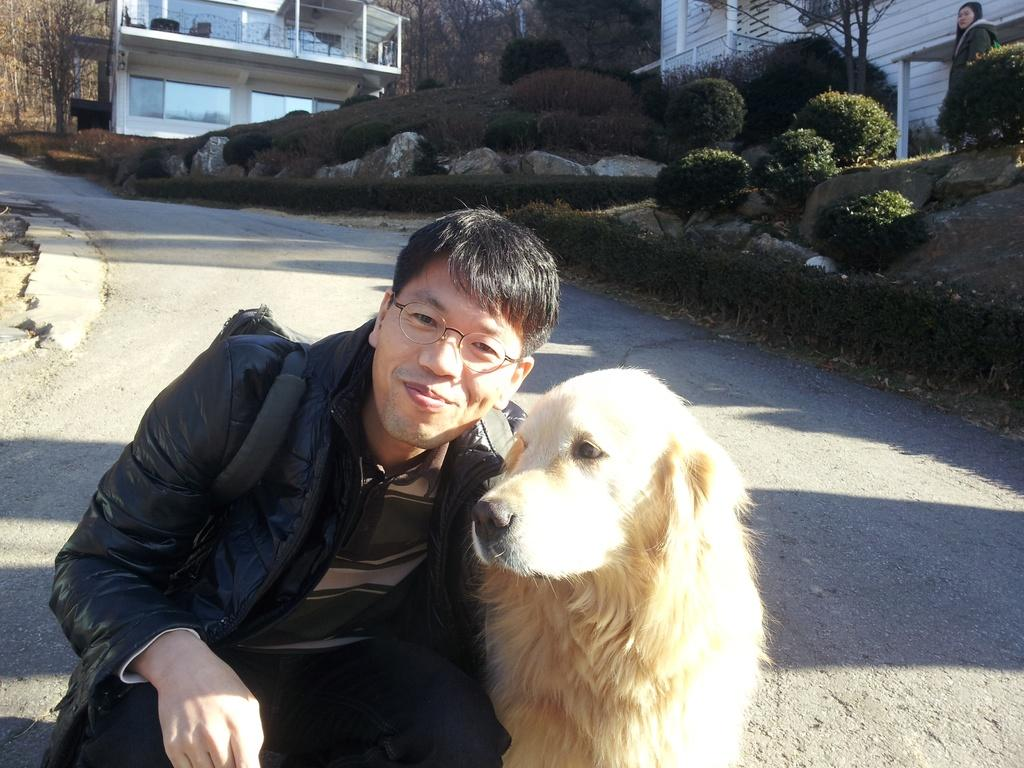What is the man in the image doing? The man is sitting and smiling in the image. What animal is next to the man? There is a dog next to the man. What can be seen in the distance in the image? There are buildings, trees, and bushes in the background of the image. Are there any other people visible in the image? Yes, there is a lady in the background of the image. What type of lamp is the doctor using to examine the ants in the image? There is no doctor, lamp, or ants present in the image. 